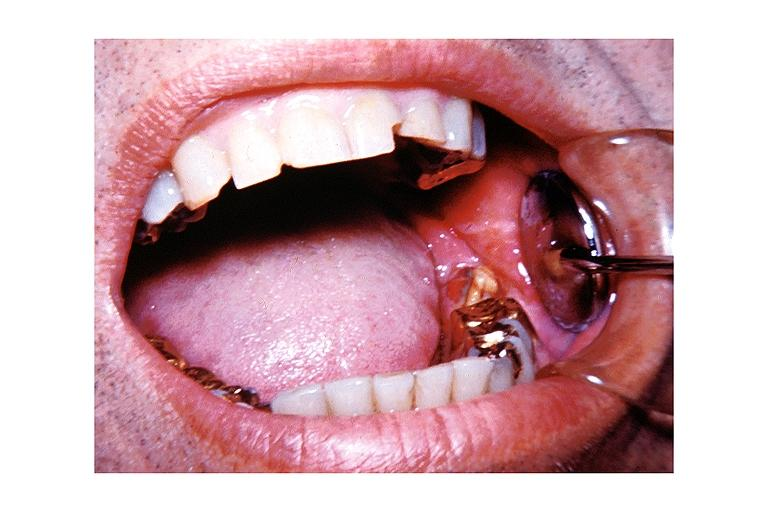s oral present?
Answer the question using a single word or phrase. Yes 